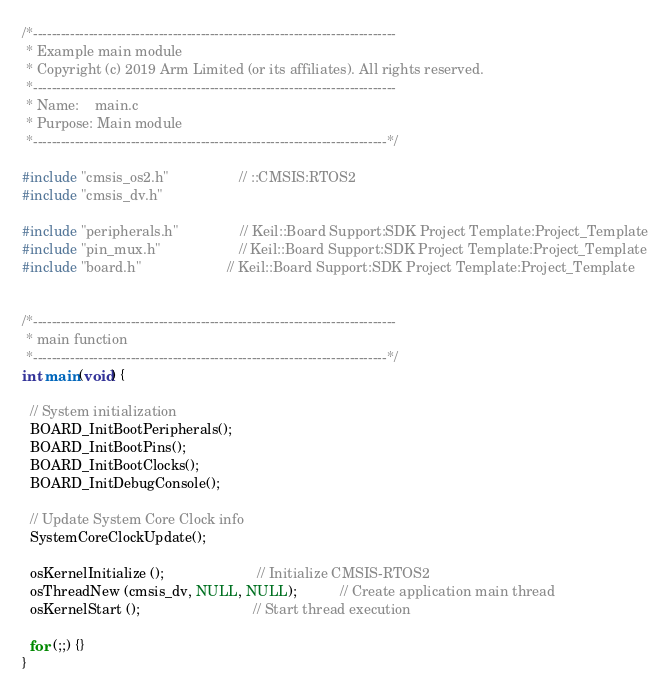<code> <loc_0><loc_0><loc_500><loc_500><_C_>/*------------------------------------------------------------------------------
 * Example main module
 * Copyright (c) 2019 Arm Limited (or its affiliates). All rights reserved.
 *------------------------------------------------------------------------------
 * Name:    main.c
 * Purpose: Main module
 *----------------------------------------------------------------------------*/

#include "cmsis_os2.h"                  // ::CMSIS:RTOS2
#include "cmsis_dv.h"

#include "peripherals.h"                // Keil::Board Support:SDK Project Template:Project_Template
#include "pin_mux.h"                    // Keil::Board Support:SDK Project Template:Project_Template
#include "board.h"                      // Keil::Board Support:SDK Project Template:Project_Template


/*------------------------------------------------------------------------------
 * main function
 *----------------------------------------------------------------------------*/
int main(void) {

  // System initialization
  BOARD_InitBootPeripherals();
  BOARD_InitBootPins();
  BOARD_InitBootClocks();
  BOARD_InitDebugConsole();

  // Update System Core Clock info
  SystemCoreClockUpdate();

  osKernelInitialize ();                        // Initialize CMSIS-RTOS2
  osThreadNew (cmsis_dv, NULL, NULL);           // Create application main thread
  osKernelStart ();                             // Start thread execution

  for (;;) {}
}
</code> 